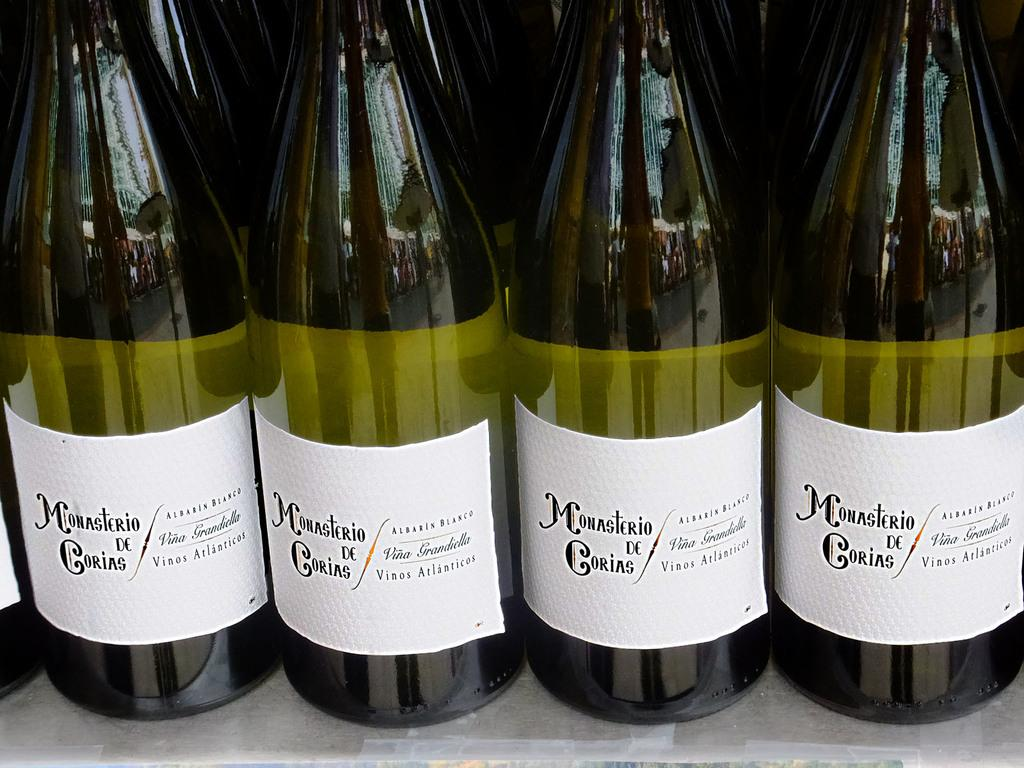<image>
Create a compact narrative representing the image presented. Bottles of Monasterio De Gorias wine lined up in a row on a table. 